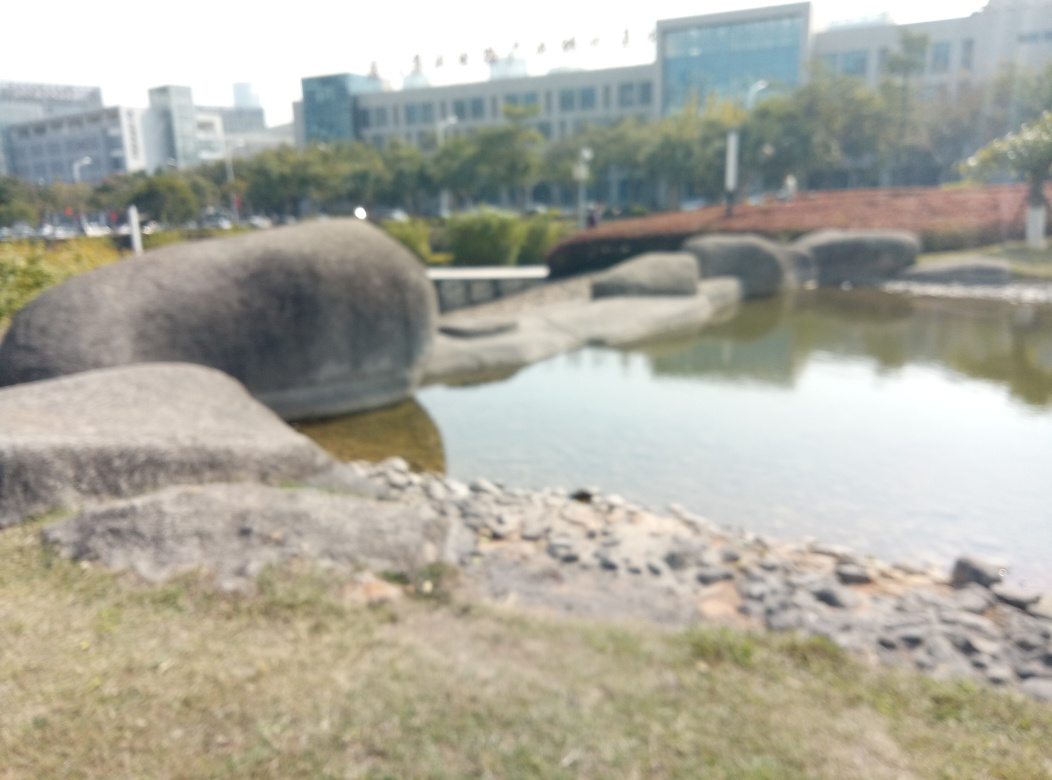Can you describe the atmosphere or mood that this image conveys? The image exudes a serene and contemplative mood. The soft focus blurs the details of the rocks and water, creating an ethereal and dreamlike quality that may invoke feelings of calmness and reflection in the viewer. The presence of nature without the hustle of urban life further enhances this peaceful atmosphere. How might this setting be used as a subject in different artistic mediums, such as painting or poetry? As a subject for painting, the blend of natural elements offers a rich tapestry of textures and shapes, allowing an artist to play with degrees of focus and abstraction. In poetry, this setting provides a metaphor for inner peace or solitude, inviting language that reflects on the interplay of stillness and flow, as symbolized by the static rocks and gentle water. 